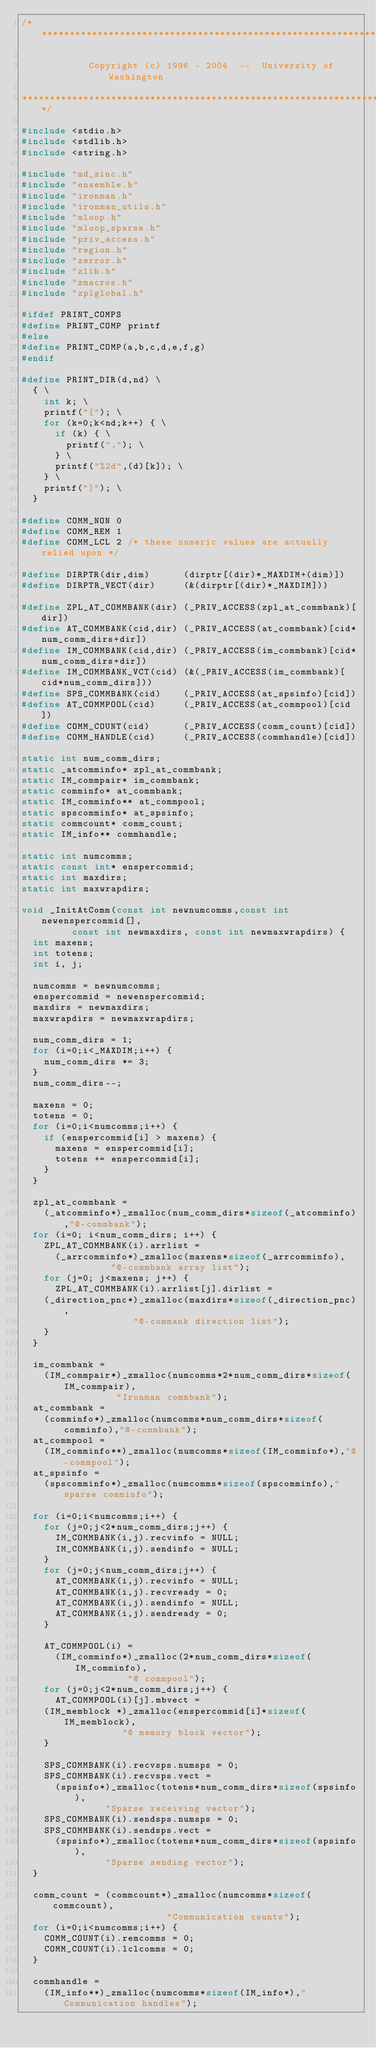Convert code to text. <code><loc_0><loc_0><loc_500><loc_500><_C_>/******************************************************************************

            Copyright (c) 1996 - 2004  --  University of Washington

******************************************************************************/

#include <stdio.h>
#include <stdlib.h>
#include <string.h>

#include "md_zinc.h"
#include "ensemble.h"
#include "ironman.h"
#include "ironman_utils.h"
#include "mloop.h"
#include "mloop_sparse.h"
#include "priv_access.h"
#include "region.h"
#include "zerror.h"
#include "zlib.h"
#include "zmacros.h"
#include "zplglobal.h"

#ifdef PRINT_COMPS
#define PRINT_COMP printf
#else
#define PRINT_COMP(a,b,c,d,e,f,g)
#endif

#define PRINT_DIR(d,nd) \
  { \
    int k; \
    printf("["); \
    for (k=0;k<nd;k++) { \
      if (k) { \
        printf(","); \
      } \
      printf("%2d",(d)[k]); \
    } \
    printf("]"); \
  }

#define COMM_NON 0
#define COMM_REM 1
#define COMM_LCL 2 /* these numeric values are actually relied upon */

#define DIRPTR(dir,dim)      (dirptr[(dir)*_MAXDIM+(dim)])
#define DIRPTR_VECT(dir)     (&(dirptr[(dir)*_MAXDIM]))

#define ZPL_AT_COMMBANK(dir) (_PRIV_ACCESS(zpl_at_commbank)[dir])
#define AT_COMMBANK(cid,dir) (_PRIV_ACCESS(at_commbank)[cid*num_comm_dirs+dir])
#define IM_COMMBANK(cid,dir) (_PRIV_ACCESS(im_commbank)[cid*num_comm_dirs+dir])
#define IM_COMMBANK_VCT(cid) (&(_PRIV_ACCESS(im_commbank)[cid*num_comm_dirs]))
#define SPS_COMMBANK(cid)    (_PRIV_ACCESS(at_spsinfo)[cid])
#define AT_COMMPOOL(cid)     (_PRIV_ACCESS(at_commpool)[cid])
#define COMM_COUNT(cid)      (_PRIV_ACCESS(comm_count)[cid])
#define COMM_HANDLE(cid)     (_PRIV_ACCESS(commhandle)[cid])

static int num_comm_dirs;
static _atcomminfo* zpl_at_commbank;
static IM_commpair* im_commbank;
static comminfo* at_commbank;
static IM_comminfo** at_commpool;
static spscomminfo* at_spsinfo;
static commcount* comm_count;
static IM_info** commhandle;

static int numcomms;
static const int* enspercommid;
static int maxdirs;
static int maxwrapdirs;

void _InitAtComm(const int newnumcomms,const int newenspercommid[],
		 const int newmaxdirs, const int newmaxwrapdirs) {
  int maxens;
  int totens;
  int i, j;

  numcomms = newnumcomms;
  enspercommid = newenspercommid;
  maxdirs = newmaxdirs;
  maxwrapdirs = newmaxwrapdirs;

  num_comm_dirs = 1;
  for (i=0;i<_MAXDIM;i++) {
    num_comm_dirs *= 3;
  }
  num_comm_dirs--;

  maxens = 0;
  totens = 0;
  for (i=0;i<numcomms;i++) {
    if (enspercommid[i] > maxens) {
      maxens = enspercommid[i];
      totens += enspercommid[i];
    }
  }

  zpl_at_commbank =
    (_atcomminfo*)_zmalloc(num_comm_dirs*sizeof(_atcomminfo),"@-commbank");
  for (i=0; i<num_comm_dirs; i++) {
    ZPL_AT_COMMBANK(i).arrlist = 
      (_arrcomminfo*)_zmalloc(maxens*sizeof(_arrcomminfo),
				"@-commbank array list");
    for (j=0; j<maxens; j++) {
      ZPL_AT_COMMBANK(i).arrlist[j].dirlist =
	(_direction_pnc*)_zmalloc(maxdirs*sizeof(_direction_pnc),
				    "@-commank direction list");
    }
  }

  im_commbank = 
    (IM_commpair*)_zmalloc(numcomms*2*num_comm_dirs*sizeof(IM_commpair),
			     "Ironman commbank");
  at_commbank = 
    (comminfo*)_zmalloc(numcomms*num_comm_dirs*sizeof(comminfo),"@-commbank");
  at_commpool = 
    (IM_comminfo**)_zmalloc(numcomms*sizeof(IM_comminfo*),"@-commpool");
  at_spsinfo = 
    (spscomminfo*)_zmalloc(numcomms*sizeof(spscomminfo),"sparse comminfo");

  for (i=0;i<numcomms;i++) {
    for (j=0;j<2*num_comm_dirs;j++) {
      IM_COMMBANK(i,j).recvinfo = NULL;
      IM_COMMBANK(i,j).sendinfo = NULL;
    }
    for (j=0;j<num_comm_dirs;j++) {
      AT_COMMBANK(i,j).recvinfo = NULL;
      AT_COMMBANK(i,j).recvready = 0;
      AT_COMMBANK(i,j).sendinfo = NULL;
      AT_COMMBANK(i,j).sendready = 0;
    }

    AT_COMMPOOL(i) = 
      (IM_comminfo*)_zmalloc(2*num_comm_dirs*sizeof(IM_comminfo),
			       "@ commpool");
    for (j=0;j<2*num_comm_dirs;j++) {
      AT_COMMPOOL(i)[j].mbvect =
	(IM_memblock *)_zmalloc(enspercommid[i]*sizeof(IM_memblock),
				  "@ memory block vector");
    }

    SPS_COMMBANK(i).recvsps.numsps = 0;
    SPS_COMMBANK(i).recvsps.vect = 
      (spsinfo*)_zmalloc(totens*num_comm_dirs*sizeof(spsinfo),
			   "Sparse receiving vector");
    SPS_COMMBANK(i).sendsps.numsps = 0;
    SPS_COMMBANK(i).sendsps.vect = 
      (spsinfo*)_zmalloc(totens*num_comm_dirs*sizeof(spsinfo),
			   "Sparse sending vector");
  }

  comm_count = (commcount*)_zmalloc(numcomms*sizeof(commcount),
						  "Communication counts");
  for (i=0;i<numcomms;i++) {
    COMM_COUNT(i).remcomms = 0;
    COMM_COUNT(i).lclcomms = 0;
  }

  commhandle =
    (IM_info**)_zmalloc(numcomms*sizeof(IM_info*),"Communication handles");
</code> 